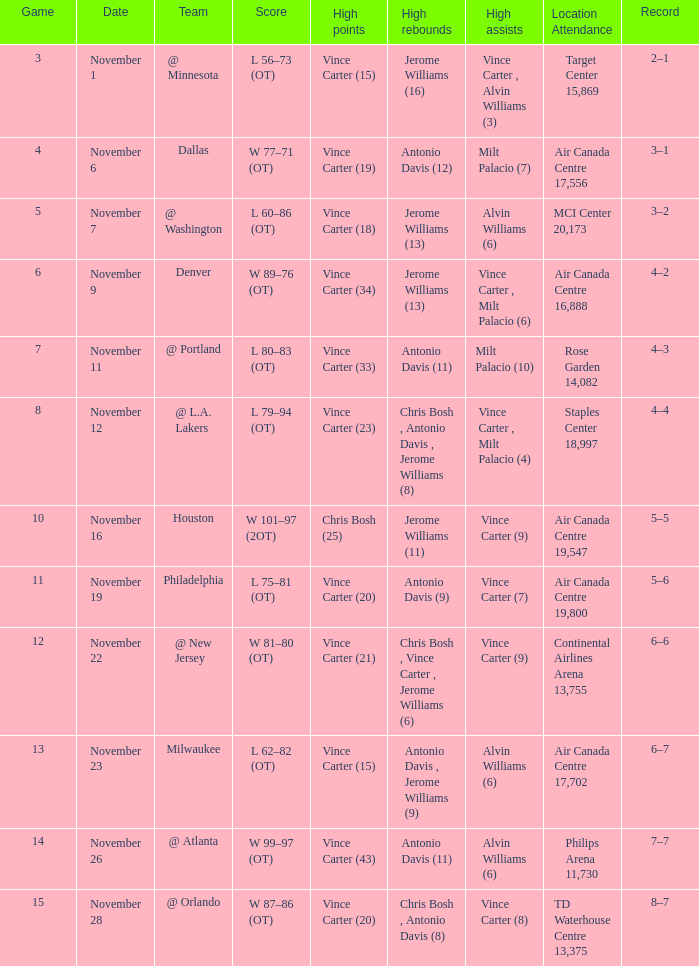On what date was the attendance at Continental Airlines Arena 13,755? November 22. 